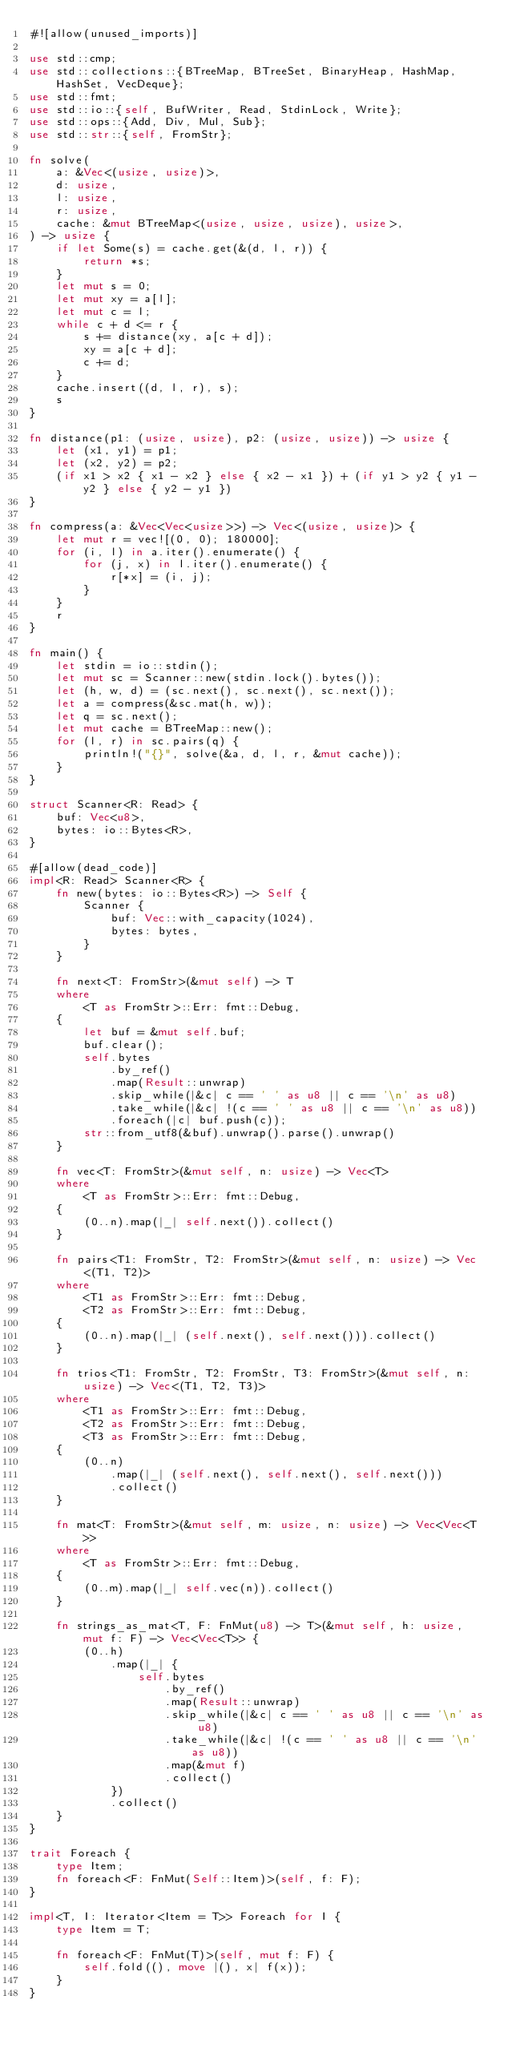<code> <loc_0><loc_0><loc_500><loc_500><_Rust_>#![allow(unused_imports)]

use std::cmp;
use std::collections::{BTreeMap, BTreeSet, BinaryHeap, HashMap, HashSet, VecDeque};
use std::fmt;
use std::io::{self, BufWriter, Read, StdinLock, Write};
use std::ops::{Add, Div, Mul, Sub};
use std::str::{self, FromStr};

fn solve(
    a: &Vec<(usize, usize)>,
    d: usize,
    l: usize,
    r: usize,
    cache: &mut BTreeMap<(usize, usize, usize), usize>,
) -> usize {
    if let Some(s) = cache.get(&(d, l, r)) {
        return *s;
    }
    let mut s = 0;
    let mut xy = a[l];
    let mut c = l;
    while c + d <= r {
        s += distance(xy, a[c + d]);
        xy = a[c + d];
        c += d;
    }
    cache.insert((d, l, r), s);
    s
}

fn distance(p1: (usize, usize), p2: (usize, usize)) -> usize {
    let (x1, y1) = p1;
    let (x2, y2) = p2;
    (if x1 > x2 { x1 - x2 } else { x2 - x1 }) + (if y1 > y2 { y1 - y2 } else { y2 - y1 })
}

fn compress(a: &Vec<Vec<usize>>) -> Vec<(usize, usize)> {
    let mut r = vec![(0, 0); 180000];
    for (i, l) in a.iter().enumerate() {
        for (j, x) in l.iter().enumerate() {
            r[*x] = (i, j);
        }
    }
    r
}

fn main() {
    let stdin = io::stdin();
    let mut sc = Scanner::new(stdin.lock().bytes());
    let (h, w, d) = (sc.next(), sc.next(), sc.next());
    let a = compress(&sc.mat(h, w));
    let q = sc.next();
    let mut cache = BTreeMap::new();
    for (l, r) in sc.pairs(q) {
        println!("{}", solve(&a, d, l, r, &mut cache));
    }
}

struct Scanner<R: Read> {
    buf: Vec<u8>,
    bytes: io::Bytes<R>,
}

#[allow(dead_code)]
impl<R: Read> Scanner<R> {
    fn new(bytes: io::Bytes<R>) -> Self {
        Scanner {
            buf: Vec::with_capacity(1024),
            bytes: bytes,
        }
    }

    fn next<T: FromStr>(&mut self) -> T
    where
        <T as FromStr>::Err: fmt::Debug,
    {
        let buf = &mut self.buf;
        buf.clear();
        self.bytes
            .by_ref()
            .map(Result::unwrap)
            .skip_while(|&c| c == ' ' as u8 || c == '\n' as u8)
            .take_while(|&c| !(c == ' ' as u8 || c == '\n' as u8))
            .foreach(|c| buf.push(c));
        str::from_utf8(&buf).unwrap().parse().unwrap()
    }

    fn vec<T: FromStr>(&mut self, n: usize) -> Vec<T>
    where
        <T as FromStr>::Err: fmt::Debug,
    {
        (0..n).map(|_| self.next()).collect()
    }

    fn pairs<T1: FromStr, T2: FromStr>(&mut self, n: usize) -> Vec<(T1, T2)>
    where
        <T1 as FromStr>::Err: fmt::Debug,
        <T2 as FromStr>::Err: fmt::Debug,
    {
        (0..n).map(|_| (self.next(), self.next())).collect()
    }

    fn trios<T1: FromStr, T2: FromStr, T3: FromStr>(&mut self, n: usize) -> Vec<(T1, T2, T3)>
    where
        <T1 as FromStr>::Err: fmt::Debug,
        <T2 as FromStr>::Err: fmt::Debug,
        <T3 as FromStr>::Err: fmt::Debug,
    {
        (0..n)
            .map(|_| (self.next(), self.next(), self.next()))
            .collect()
    }

    fn mat<T: FromStr>(&mut self, m: usize, n: usize) -> Vec<Vec<T>>
    where
        <T as FromStr>::Err: fmt::Debug,
    {
        (0..m).map(|_| self.vec(n)).collect()
    }

    fn strings_as_mat<T, F: FnMut(u8) -> T>(&mut self, h: usize, mut f: F) -> Vec<Vec<T>> {
        (0..h)
            .map(|_| {
                self.bytes
                    .by_ref()
                    .map(Result::unwrap)
                    .skip_while(|&c| c == ' ' as u8 || c == '\n' as u8)
                    .take_while(|&c| !(c == ' ' as u8 || c == '\n' as u8))
                    .map(&mut f)
                    .collect()
            })
            .collect()
    }
}

trait Foreach {
    type Item;
    fn foreach<F: FnMut(Self::Item)>(self, f: F);
}

impl<T, I: Iterator<Item = T>> Foreach for I {
    type Item = T;

    fn foreach<F: FnMut(T)>(self, mut f: F) {
        self.fold((), move |(), x| f(x));
    }
}
</code> 